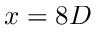<formula> <loc_0><loc_0><loc_500><loc_500>x = 8 D</formula> 